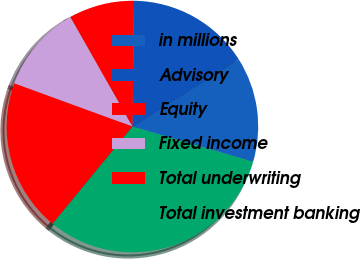Convert chart to OTSL. <chart><loc_0><loc_0><loc_500><loc_500><pie_chart><fcel>in millions<fcel>Advisory<fcel>Equity<fcel>Fixed income<fcel>Total underwriting<fcel>Total investment banking<nl><fcel>13.51%<fcel>15.81%<fcel>8.42%<fcel>11.21%<fcel>19.63%<fcel>31.42%<nl></chart> 